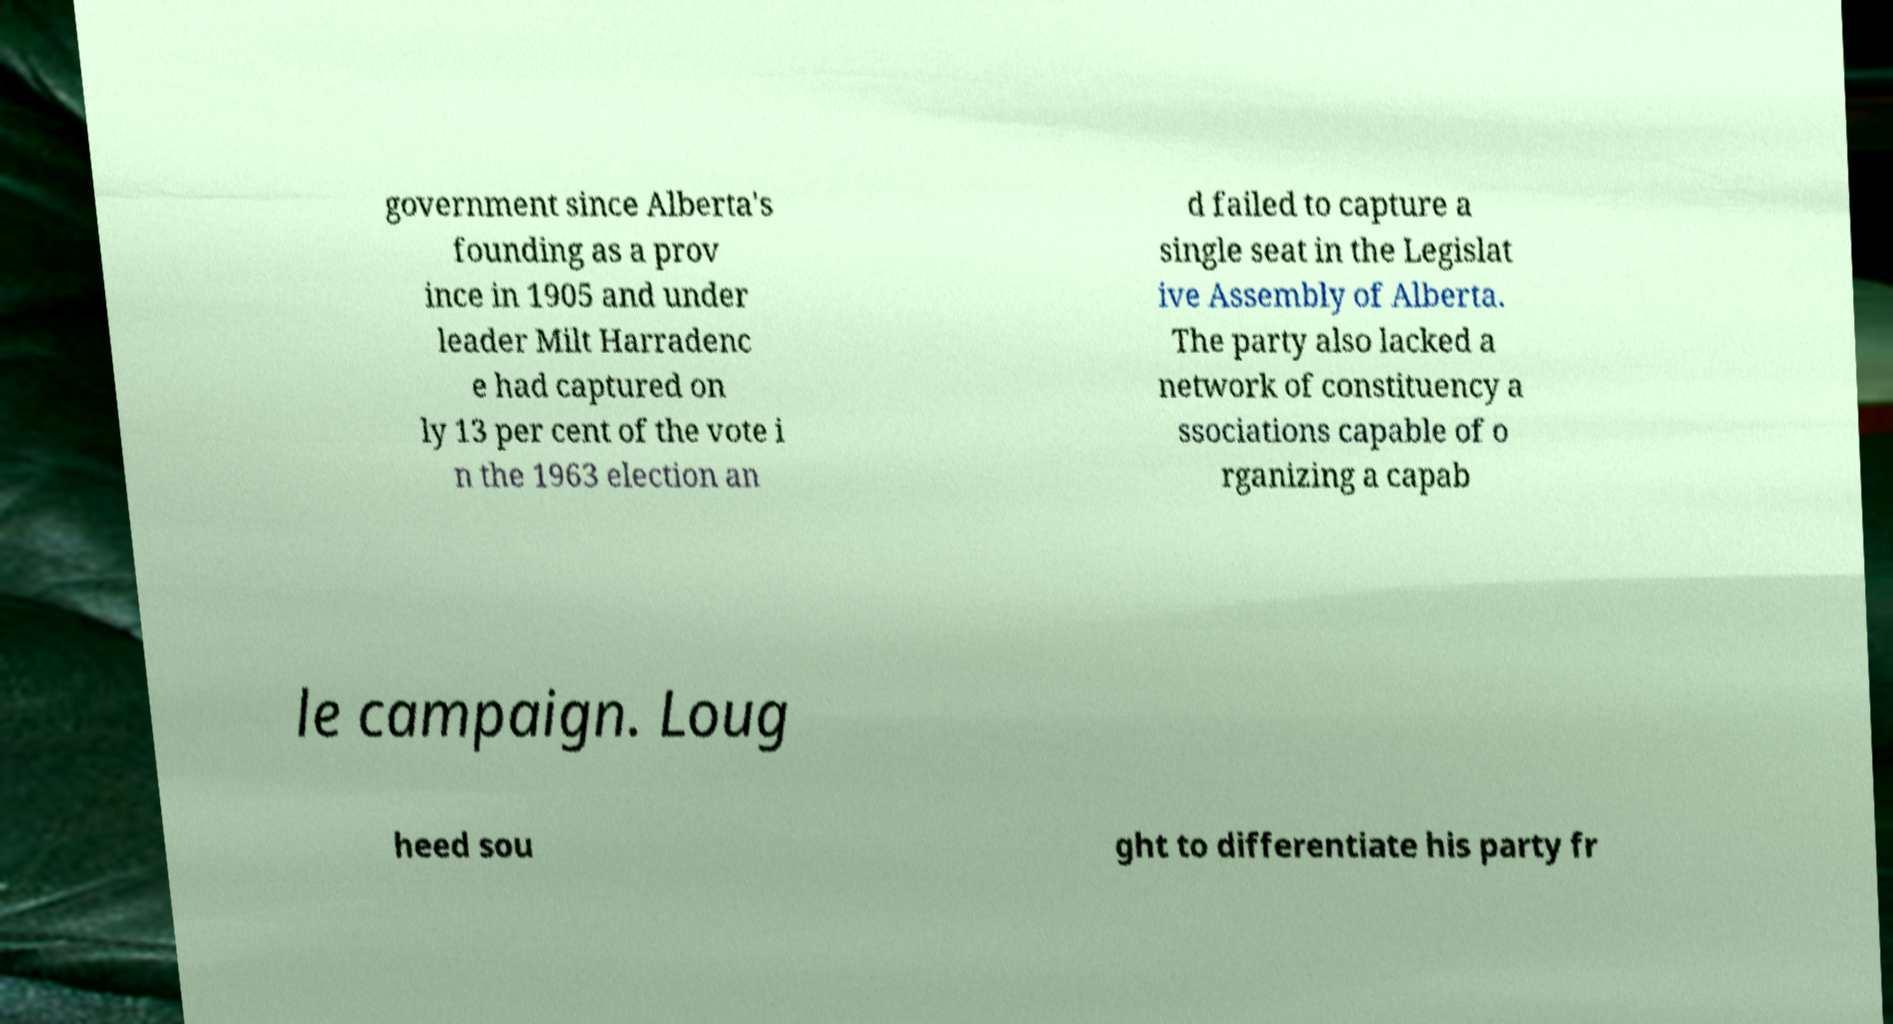What messages or text are displayed in this image? I need them in a readable, typed format. government since Alberta's founding as a prov ince in 1905 and under leader Milt Harradenc e had captured on ly 13 per cent of the vote i n the 1963 election an d failed to capture a single seat in the Legislat ive Assembly of Alberta. The party also lacked a network of constituency a ssociations capable of o rganizing a capab le campaign. Loug heed sou ght to differentiate his party fr 